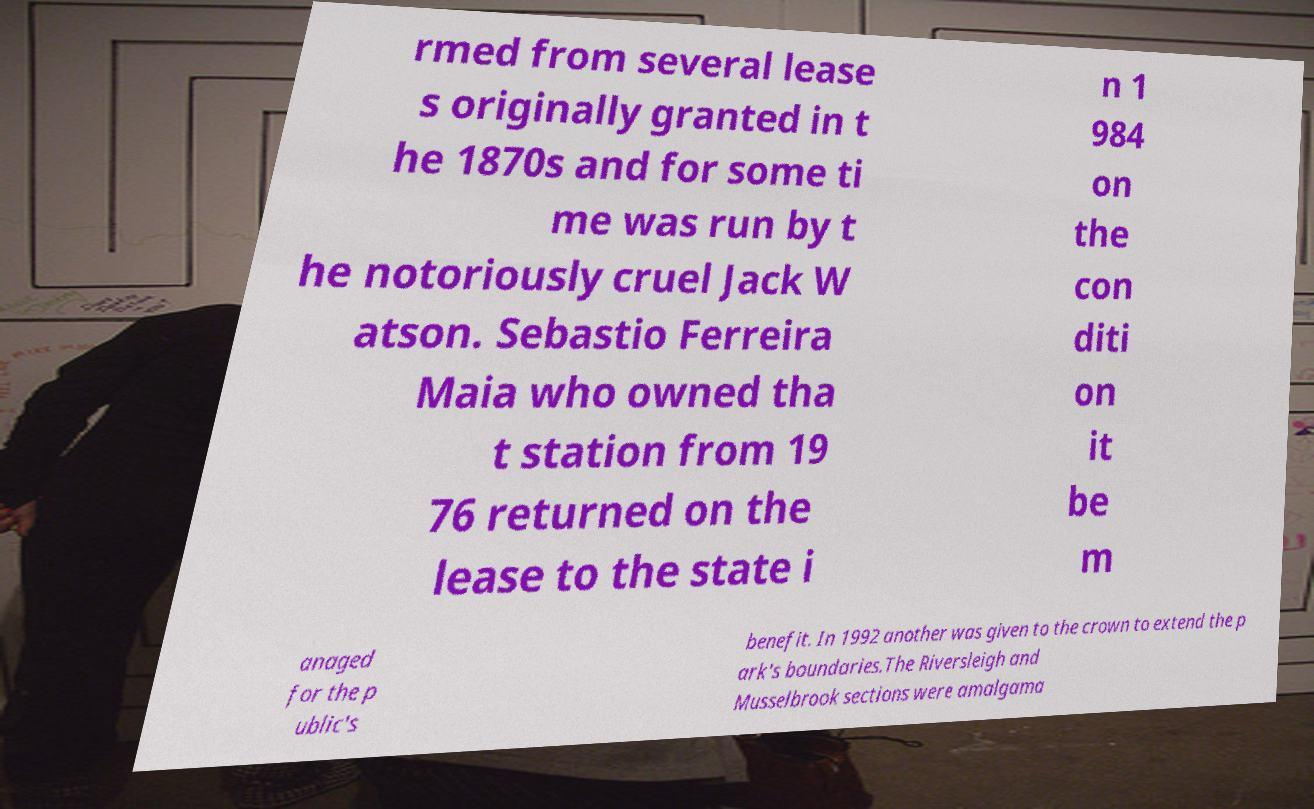I need the written content from this picture converted into text. Can you do that? rmed from several lease s originally granted in t he 1870s and for some ti me was run by t he notoriously cruel Jack W atson. Sebastio Ferreira Maia who owned tha t station from 19 76 returned on the lease to the state i n 1 984 on the con diti on it be m anaged for the p ublic's benefit. In 1992 another was given to the crown to extend the p ark's boundaries.The Riversleigh and Musselbrook sections were amalgama 